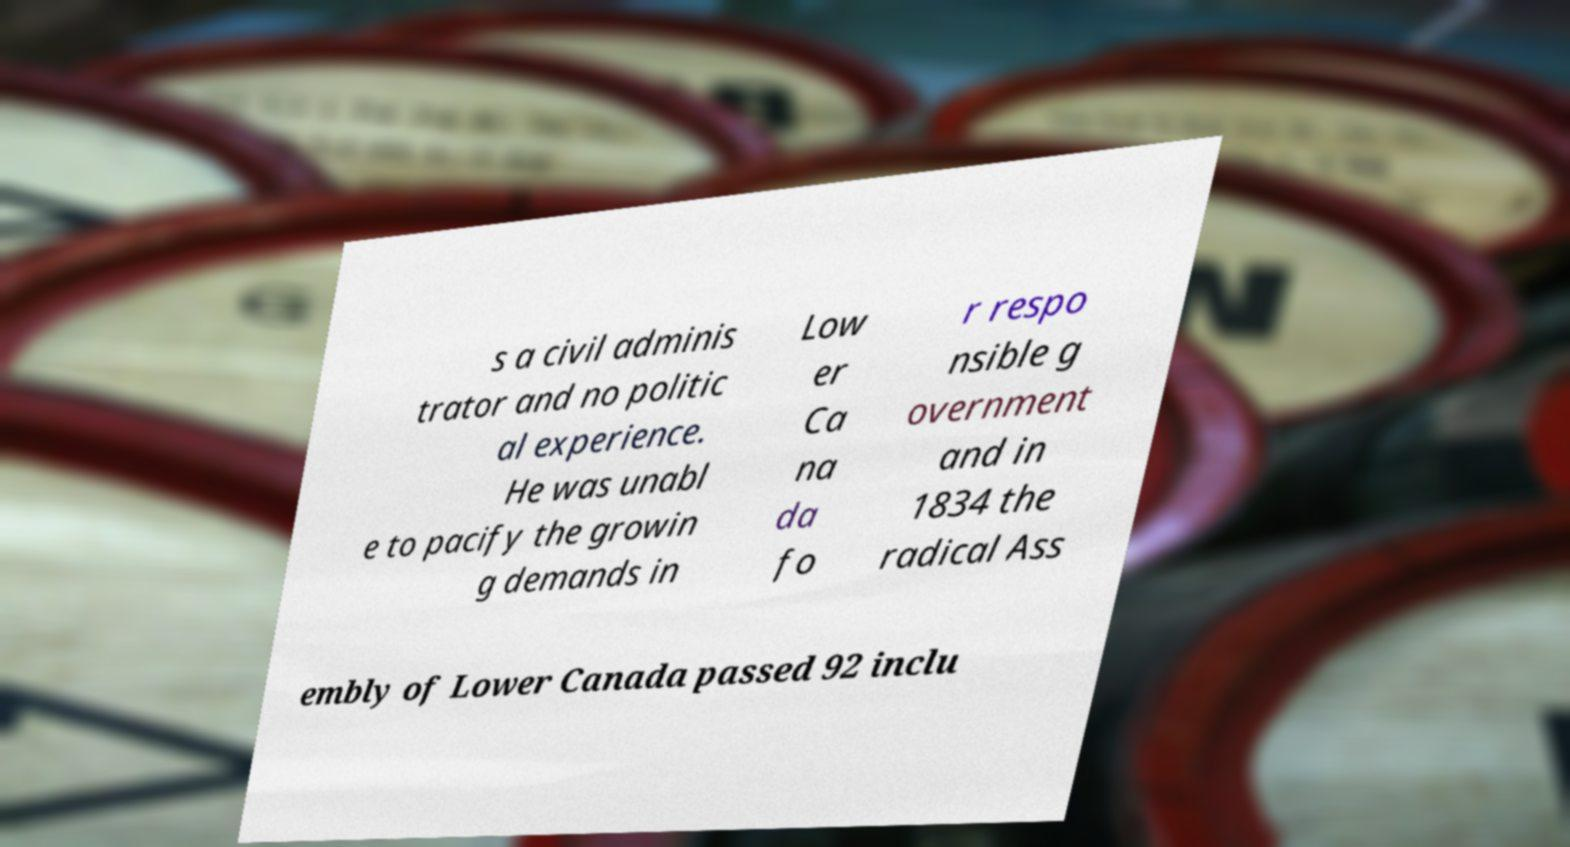There's text embedded in this image that I need extracted. Can you transcribe it verbatim? s a civil adminis trator and no politic al experience. He was unabl e to pacify the growin g demands in Low er Ca na da fo r respo nsible g overnment and in 1834 the radical Ass embly of Lower Canada passed 92 inclu 